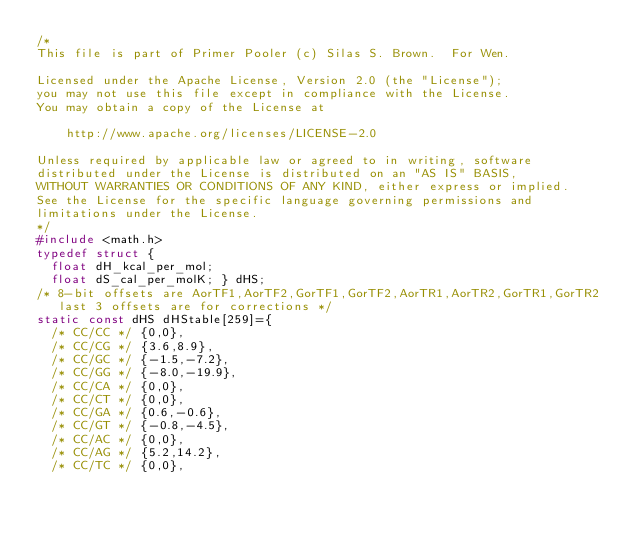<code> <loc_0><loc_0><loc_500><loc_500><_C_>/*
This file is part of Primer Pooler (c) Silas S. Brown.  For Wen.

Licensed under the Apache License, Version 2.0 (the "License");
you may not use this file except in compliance with the License.
You may obtain a copy of the License at

    http://www.apache.org/licenses/LICENSE-2.0

Unless required by applicable law or agreed to in writing, software
distributed under the License is distributed on an "AS IS" BASIS,
WITHOUT WARRANTIES OR CONDITIONS OF ANY KIND, either express or implied.
See the License for the specific language governing permissions and
limitations under the License.
*/
#include <math.h>
typedef struct {
  float dH_kcal_per_mol;
  float dS_cal_per_molK; } dHS;
/* 8-bit offsets are AorTF1,AorTF2,GorTF1,GorTF2,AorTR1,AorTR2,GorTR1,GorTR2
   last 3 offsets are for corrections */
static const dHS dHStable[259]={
  /* CC/CC */ {0,0},
  /* CC/CG */ {3.6,8.9},
  /* CC/GC */ {-1.5,-7.2},
  /* CC/GG */ {-8.0,-19.9},
  /* CC/CA */ {0,0},
  /* CC/CT */ {0,0},
  /* CC/GA */ {0.6,-0.6},
  /* CC/GT */ {-0.8,-4.5},
  /* CC/AC */ {0,0},
  /* CC/AG */ {5.2,14.2},
  /* CC/TC */ {0,0},</code> 